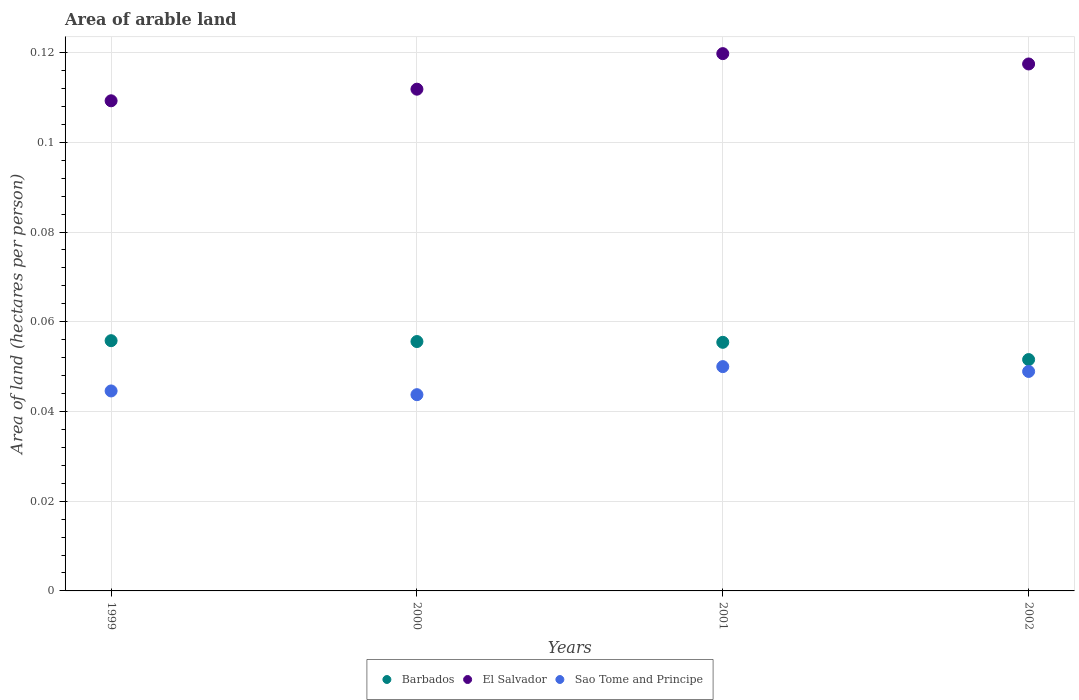What is the total arable land in El Salvador in 1999?
Provide a short and direct response. 0.11. Across all years, what is the maximum total arable land in Sao Tome and Principe?
Keep it short and to the point. 0.05. Across all years, what is the minimum total arable land in Sao Tome and Principe?
Ensure brevity in your answer.  0.04. In which year was the total arable land in Sao Tome and Principe maximum?
Give a very brief answer. 2001. In which year was the total arable land in Sao Tome and Principe minimum?
Offer a terse response. 2000. What is the total total arable land in Sao Tome and Principe in the graph?
Make the answer very short. 0.19. What is the difference between the total arable land in El Salvador in 2000 and that in 2001?
Keep it short and to the point. -0.01. What is the difference between the total arable land in Barbados in 2002 and the total arable land in El Salvador in 2001?
Your answer should be compact. -0.07. What is the average total arable land in Sao Tome and Principe per year?
Your response must be concise. 0.05. In the year 2001, what is the difference between the total arable land in Barbados and total arable land in El Salvador?
Your answer should be very brief. -0.06. In how many years, is the total arable land in Barbados greater than 0.10400000000000001 hectares per person?
Offer a very short reply. 0. What is the ratio of the total arable land in El Salvador in 2000 to that in 2001?
Give a very brief answer. 0.93. What is the difference between the highest and the second highest total arable land in El Salvador?
Ensure brevity in your answer.  0. What is the difference between the highest and the lowest total arable land in El Salvador?
Your answer should be compact. 0.01. Is the sum of the total arable land in Barbados in 1999 and 2001 greater than the maximum total arable land in Sao Tome and Principe across all years?
Your answer should be compact. Yes. Is it the case that in every year, the sum of the total arable land in El Salvador and total arable land in Barbados  is greater than the total arable land in Sao Tome and Principe?
Provide a short and direct response. Yes. Is the total arable land in Barbados strictly greater than the total arable land in El Salvador over the years?
Your answer should be very brief. No. Is the total arable land in Barbados strictly less than the total arable land in El Salvador over the years?
Ensure brevity in your answer.  Yes. How many years are there in the graph?
Give a very brief answer. 4. What is the difference between two consecutive major ticks on the Y-axis?
Provide a succinct answer. 0.02. Are the values on the major ticks of Y-axis written in scientific E-notation?
Ensure brevity in your answer.  No. Does the graph contain any zero values?
Keep it short and to the point. No. Does the graph contain grids?
Offer a terse response. Yes. How are the legend labels stacked?
Your answer should be compact. Horizontal. What is the title of the graph?
Make the answer very short. Area of arable land. What is the label or title of the Y-axis?
Offer a terse response. Area of land (hectares per person). What is the Area of land (hectares per person) in Barbados in 1999?
Make the answer very short. 0.06. What is the Area of land (hectares per person) of El Salvador in 1999?
Make the answer very short. 0.11. What is the Area of land (hectares per person) of Sao Tome and Principe in 1999?
Provide a succinct answer. 0.04. What is the Area of land (hectares per person) in Barbados in 2000?
Keep it short and to the point. 0.06. What is the Area of land (hectares per person) of El Salvador in 2000?
Ensure brevity in your answer.  0.11. What is the Area of land (hectares per person) of Sao Tome and Principe in 2000?
Your answer should be very brief. 0.04. What is the Area of land (hectares per person) of Barbados in 2001?
Provide a short and direct response. 0.06. What is the Area of land (hectares per person) in El Salvador in 2001?
Make the answer very short. 0.12. What is the Area of land (hectares per person) in Sao Tome and Principe in 2001?
Provide a short and direct response. 0.05. What is the Area of land (hectares per person) of Barbados in 2002?
Your answer should be compact. 0.05. What is the Area of land (hectares per person) of El Salvador in 2002?
Your answer should be compact. 0.12. What is the Area of land (hectares per person) of Sao Tome and Principe in 2002?
Keep it short and to the point. 0.05. Across all years, what is the maximum Area of land (hectares per person) in Barbados?
Your response must be concise. 0.06. Across all years, what is the maximum Area of land (hectares per person) of El Salvador?
Keep it short and to the point. 0.12. Across all years, what is the maximum Area of land (hectares per person) of Sao Tome and Principe?
Keep it short and to the point. 0.05. Across all years, what is the minimum Area of land (hectares per person) of Barbados?
Provide a short and direct response. 0.05. Across all years, what is the minimum Area of land (hectares per person) of El Salvador?
Your answer should be compact. 0.11. Across all years, what is the minimum Area of land (hectares per person) in Sao Tome and Principe?
Your response must be concise. 0.04. What is the total Area of land (hectares per person) of Barbados in the graph?
Your response must be concise. 0.22. What is the total Area of land (hectares per person) in El Salvador in the graph?
Offer a very short reply. 0.46. What is the total Area of land (hectares per person) in Sao Tome and Principe in the graph?
Keep it short and to the point. 0.19. What is the difference between the Area of land (hectares per person) of Barbados in 1999 and that in 2000?
Offer a very short reply. 0. What is the difference between the Area of land (hectares per person) in El Salvador in 1999 and that in 2000?
Make the answer very short. -0. What is the difference between the Area of land (hectares per person) in Sao Tome and Principe in 1999 and that in 2000?
Make the answer very short. 0. What is the difference between the Area of land (hectares per person) of Barbados in 1999 and that in 2001?
Your response must be concise. 0. What is the difference between the Area of land (hectares per person) of El Salvador in 1999 and that in 2001?
Make the answer very short. -0.01. What is the difference between the Area of land (hectares per person) in Sao Tome and Principe in 1999 and that in 2001?
Offer a very short reply. -0.01. What is the difference between the Area of land (hectares per person) in Barbados in 1999 and that in 2002?
Offer a terse response. 0. What is the difference between the Area of land (hectares per person) of El Salvador in 1999 and that in 2002?
Your answer should be very brief. -0.01. What is the difference between the Area of land (hectares per person) of Sao Tome and Principe in 1999 and that in 2002?
Your response must be concise. -0. What is the difference between the Area of land (hectares per person) in El Salvador in 2000 and that in 2001?
Make the answer very short. -0.01. What is the difference between the Area of land (hectares per person) of Sao Tome and Principe in 2000 and that in 2001?
Ensure brevity in your answer.  -0.01. What is the difference between the Area of land (hectares per person) in Barbados in 2000 and that in 2002?
Offer a very short reply. 0. What is the difference between the Area of land (hectares per person) of El Salvador in 2000 and that in 2002?
Your answer should be compact. -0.01. What is the difference between the Area of land (hectares per person) in Sao Tome and Principe in 2000 and that in 2002?
Provide a succinct answer. -0.01. What is the difference between the Area of land (hectares per person) in Barbados in 2001 and that in 2002?
Your answer should be compact. 0. What is the difference between the Area of land (hectares per person) in El Salvador in 2001 and that in 2002?
Make the answer very short. 0. What is the difference between the Area of land (hectares per person) in Sao Tome and Principe in 2001 and that in 2002?
Offer a very short reply. 0. What is the difference between the Area of land (hectares per person) in Barbados in 1999 and the Area of land (hectares per person) in El Salvador in 2000?
Provide a short and direct response. -0.06. What is the difference between the Area of land (hectares per person) in Barbados in 1999 and the Area of land (hectares per person) in Sao Tome and Principe in 2000?
Offer a terse response. 0.01. What is the difference between the Area of land (hectares per person) of El Salvador in 1999 and the Area of land (hectares per person) of Sao Tome and Principe in 2000?
Keep it short and to the point. 0.07. What is the difference between the Area of land (hectares per person) in Barbados in 1999 and the Area of land (hectares per person) in El Salvador in 2001?
Make the answer very short. -0.06. What is the difference between the Area of land (hectares per person) of Barbados in 1999 and the Area of land (hectares per person) of Sao Tome and Principe in 2001?
Provide a short and direct response. 0.01. What is the difference between the Area of land (hectares per person) in El Salvador in 1999 and the Area of land (hectares per person) in Sao Tome and Principe in 2001?
Your answer should be very brief. 0.06. What is the difference between the Area of land (hectares per person) of Barbados in 1999 and the Area of land (hectares per person) of El Salvador in 2002?
Offer a very short reply. -0.06. What is the difference between the Area of land (hectares per person) in Barbados in 1999 and the Area of land (hectares per person) in Sao Tome and Principe in 2002?
Your answer should be very brief. 0.01. What is the difference between the Area of land (hectares per person) in El Salvador in 1999 and the Area of land (hectares per person) in Sao Tome and Principe in 2002?
Offer a very short reply. 0.06. What is the difference between the Area of land (hectares per person) in Barbados in 2000 and the Area of land (hectares per person) in El Salvador in 2001?
Your response must be concise. -0.06. What is the difference between the Area of land (hectares per person) of Barbados in 2000 and the Area of land (hectares per person) of Sao Tome and Principe in 2001?
Keep it short and to the point. 0.01. What is the difference between the Area of land (hectares per person) in El Salvador in 2000 and the Area of land (hectares per person) in Sao Tome and Principe in 2001?
Your answer should be compact. 0.06. What is the difference between the Area of land (hectares per person) of Barbados in 2000 and the Area of land (hectares per person) of El Salvador in 2002?
Your answer should be compact. -0.06. What is the difference between the Area of land (hectares per person) in Barbados in 2000 and the Area of land (hectares per person) in Sao Tome and Principe in 2002?
Your answer should be compact. 0.01. What is the difference between the Area of land (hectares per person) in El Salvador in 2000 and the Area of land (hectares per person) in Sao Tome and Principe in 2002?
Make the answer very short. 0.06. What is the difference between the Area of land (hectares per person) in Barbados in 2001 and the Area of land (hectares per person) in El Salvador in 2002?
Your answer should be very brief. -0.06. What is the difference between the Area of land (hectares per person) of Barbados in 2001 and the Area of land (hectares per person) of Sao Tome and Principe in 2002?
Offer a terse response. 0.01. What is the difference between the Area of land (hectares per person) of El Salvador in 2001 and the Area of land (hectares per person) of Sao Tome and Principe in 2002?
Your answer should be compact. 0.07. What is the average Area of land (hectares per person) of Barbados per year?
Keep it short and to the point. 0.05. What is the average Area of land (hectares per person) of El Salvador per year?
Offer a very short reply. 0.11. What is the average Area of land (hectares per person) in Sao Tome and Principe per year?
Ensure brevity in your answer.  0.05. In the year 1999, what is the difference between the Area of land (hectares per person) of Barbados and Area of land (hectares per person) of El Salvador?
Ensure brevity in your answer.  -0.05. In the year 1999, what is the difference between the Area of land (hectares per person) of Barbados and Area of land (hectares per person) of Sao Tome and Principe?
Ensure brevity in your answer.  0.01. In the year 1999, what is the difference between the Area of land (hectares per person) of El Salvador and Area of land (hectares per person) of Sao Tome and Principe?
Keep it short and to the point. 0.06. In the year 2000, what is the difference between the Area of land (hectares per person) of Barbados and Area of land (hectares per person) of El Salvador?
Make the answer very short. -0.06. In the year 2000, what is the difference between the Area of land (hectares per person) in Barbados and Area of land (hectares per person) in Sao Tome and Principe?
Your answer should be very brief. 0.01. In the year 2000, what is the difference between the Area of land (hectares per person) in El Salvador and Area of land (hectares per person) in Sao Tome and Principe?
Your answer should be compact. 0.07. In the year 2001, what is the difference between the Area of land (hectares per person) in Barbados and Area of land (hectares per person) in El Salvador?
Keep it short and to the point. -0.06. In the year 2001, what is the difference between the Area of land (hectares per person) of Barbados and Area of land (hectares per person) of Sao Tome and Principe?
Your answer should be very brief. 0.01. In the year 2001, what is the difference between the Area of land (hectares per person) of El Salvador and Area of land (hectares per person) of Sao Tome and Principe?
Provide a short and direct response. 0.07. In the year 2002, what is the difference between the Area of land (hectares per person) of Barbados and Area of land (hectares per person) of El Salvador?
Provide a short and direct response. -0.07. In the year 2002, what is the difference between the Area of land (hectares per person) of Barbados and Area of land (hectares per person) of Sao Tome and Principe?
Your answer should be compact. 0. In the year 2002, what is the difference between the Area of land (hectares per person) in El Salvador and Area of land (hectares per person) in Sao Tome and Principe?
Make the answer very short. 0.07. What is the ratio of the Area of land (hectares per person) of El Salvador in 1999 to that in 2000?
Keep it short and to the point. 0.98. What is the ratio of the Area of land (hectares per person) in Barbados in 1999 to that in 2001?
Your answer should be compact. 1.01. What is the ratio of the Area of land (hectares per person) in El Salvador in 1999 to that in 2001?
Give a very brief answer. 0.91. What is the ratio of the Area of land (hectares per person) in Sao Tome and Principe in 1999 to that in 2001?
Offer a terse response. 0.89. What is the ratio of the Area of land (hectares per person) in Barbados in 1999 to that in 2002?
Give a very brief answer. 1.08. What is the ratio of the Area of land (hectares per person) in El Salvador in 1999 to that in 2002?
Offer a very short reply. 0.93. What is the ratio of the Area of land (hectares per person) of Sao Tome and Principe in 1999 to that in 2002?
Your response must be concise. 0.91. What is the ratio of the Area of land (hectares per person) of Barbados in 2000 to that in 2001?
Provide a succinct answer. 1. What is the ratio of the Area of land (hectares per person) in El Salvador in 2000 to that in 2001?
Ensure brevity in your answer.  0.93. What is the ratio of the Area of land (hectares per person) of Sao Tome and Principe in 2000 to that in 2001?
Ensure brevity in your answer.  0.87. What is the ratio of the Area of land (hectares per person) of Barbados in 2000 to that in 2002?
Offer a very short reply. 1.08. What is the ratio of the Area of land (hectares per person) of El Salvador in 2000 to that in 2002?
Offer a very short reply. 0.95. What is the ratio of the Area of land (hectares per person) of Sao Tome and Principe in 2000 to that in 2002?
Offer a very short reply. 0.89. What is the ratio of the Area of land (hectares per person) of Barbados in 2001 to that in 2002?
Give a very brief answer. 1.07. What is the ratio of the Area of land (hectares per person) in El Salvador in 2001 to that in 2002?
Give a very brief answer. 1.02. What is the ratio of the Area of land (hectares per person) in Sao Tome and Principe in 2001 to that in 2002?
Your response must be concise. 1.02. What is the difference between the highest and the second highest Area of land (hectares per person) of El Salvador?
Make the answer very short. 0. What is the difference between the highest and the second highest Area of land (hectares per person) in Sao Tome and Principe?
Your answer should be very brief. 0. What is the difference between the highest and the lowest Area of land (hectares per person) in Barbados?
Make the answer very short. 0. What is the difference between the highest and the lowest Area of land (hectares per person) in El Salvador?
Ensure brevity in your answer.  0.01. What is the difference between the highest and the lowest Area of land (hectares per person) of Sao Tome and Principe?
Your response must be concise. 0.01. 